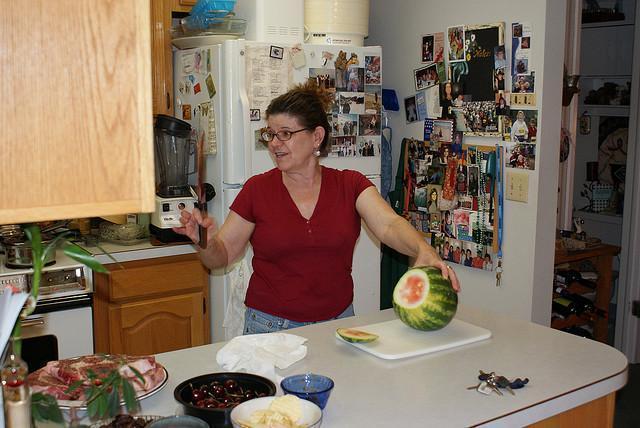What is the appliance next to the refrigerator?
Choose the right answer from the provided options to respond to the question.
Options: Tea pot, coffee maker, blender, hand mixer. Blender. 